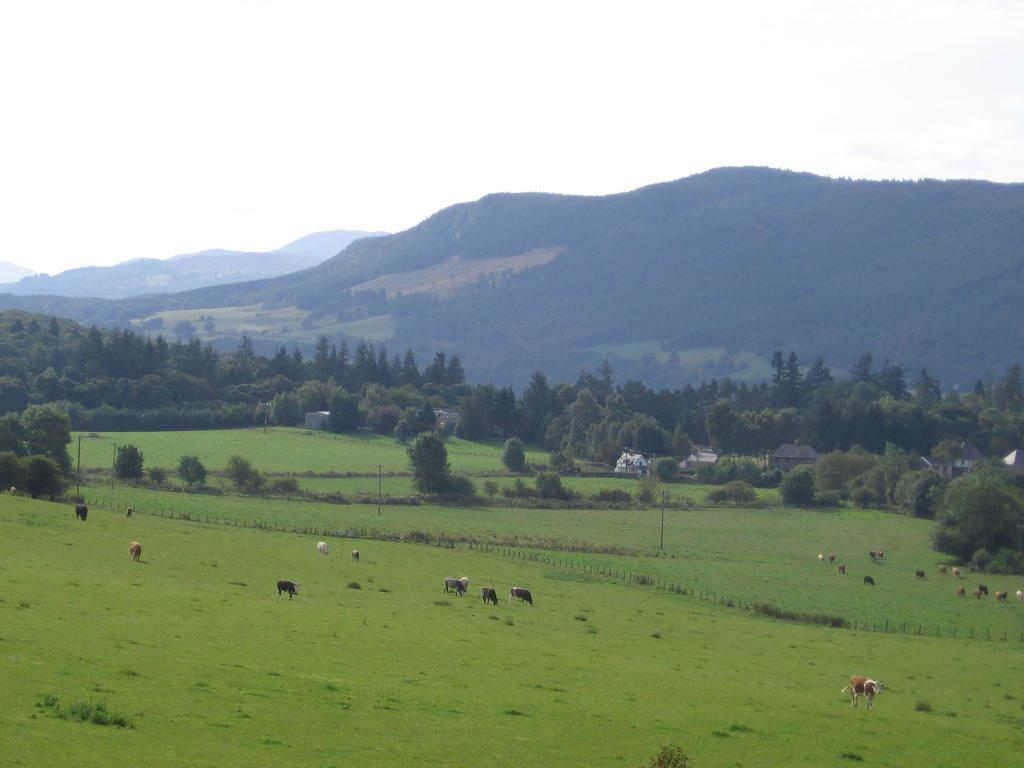What type of vegetation is present on the ground in the image? There is grass on the ground in the image. What is located in the center of the image? There are animals in the center of the image. What can be seen in the background of the image? There are trees, mountains, and houses in the background of the image. What type of gate can be seen in the image? There is no gate present in the image. Can you describe the man standing near the animals in the image? There is no man present in the image; it only features animals. 